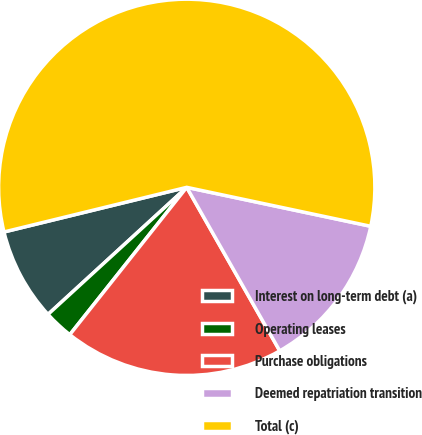Convert chart. <chart><loc_0><loc_0><loc_500><loc_500><pie_chart><fcel>Interest on long-term debt (a)<fcel>Operating leases<fcel>Purchase obligations<fcel>Deemed repatriation transition<fcel>Total (c)<nl><fcel>7.99%<fcel>2.52%<fcel>18.91%<fcel>13.45%<fcel>57.14%<nl></chart> 